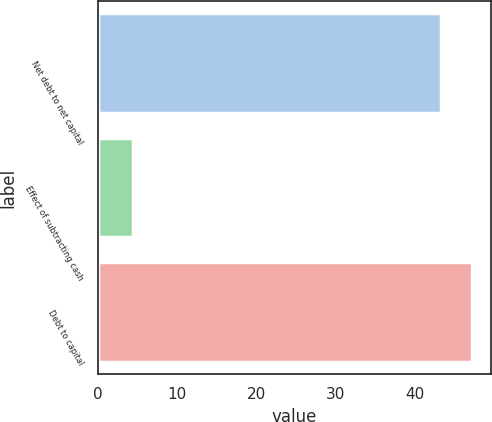Convert chart to OTSL. <chart><loc_0><loc_0><loc_500><loc_500><bar_chart><fcel>Net debt to net capital<fcel>Effect of subtracting cash<fcel>Debt to capital<nl><fcel>43.4<fcel>4.39<fcel>47.3<nl></chart> 